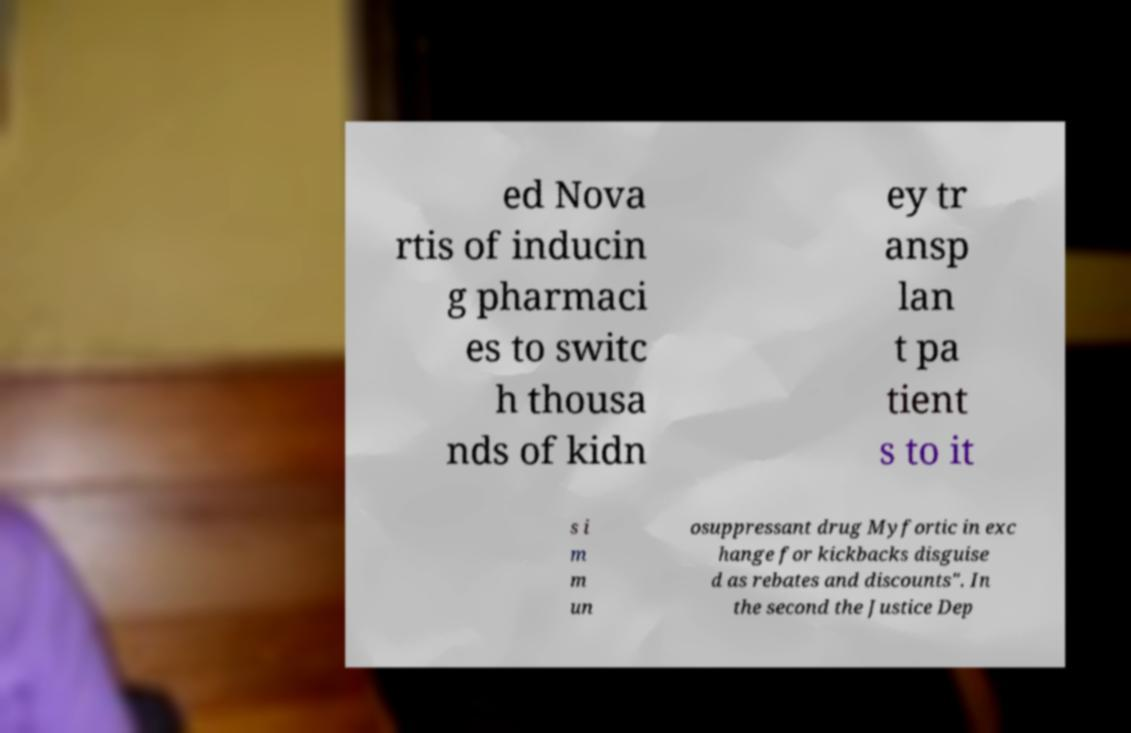Please read and relay the text visible in this image. What does it say? ed Nova rtis of inducin g pharmaci es to switc h thousa nds of kidn ey tr ansp lan t pa tient s to it s i m m un osuppressant drug Myfortic in exc hange for kickbacks disguise d as rebates and discounts". In the second the Justice Dep 